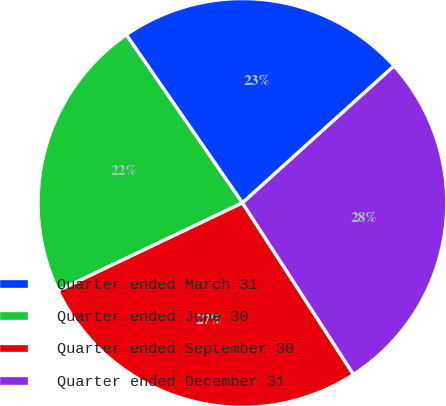Convert chart. <chart><loc_0><loc_0><loc_500><loc_500><pie_chart><fcel>Quarter ended March 31<fcel>Quarter ended June 30<fcel>Quarter ended September 30<fcel>Quarter ended December 31<nl><fcel>22.93%<fcel>22.45%<fcel>27.07%<fcel>27.55%<nl></chart> 